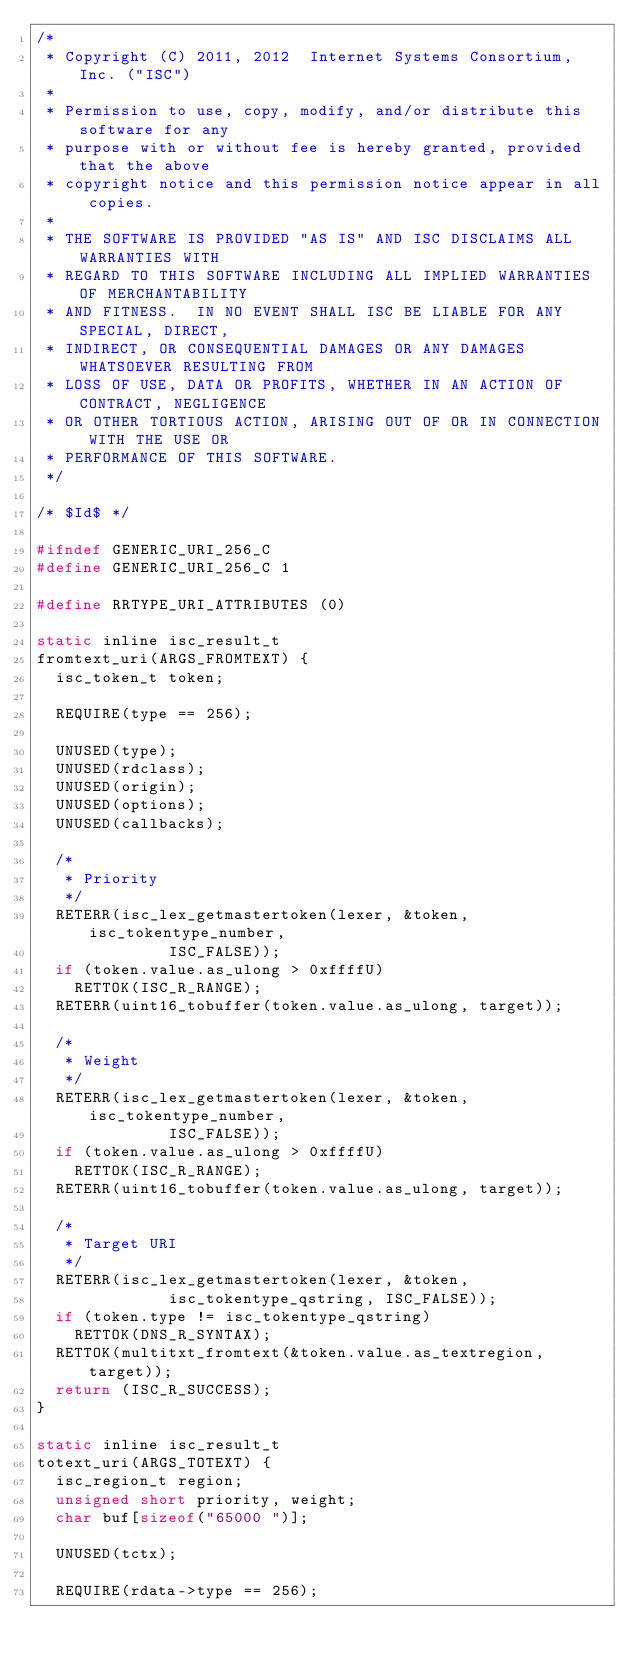Convert code to text. <code><loc_0><loc_0><loc_500><loc_500><_C_>/*
 * Copyright (C) 2011, 2012  Internet Systems Consortium, Inc. ("ISC")
 *
 * Permission to use, copy, modify, and/or distribute this software for any
 * purpose with or without fee is hereby granted, provided that the above
 * copyright notice and this permission notice appear in all copies.
 *
 * THE SOFTWARE IS PROVIDED "AS IS" AND ISC DISCLAIMS ALL WARRANTIES WITH
 * REGARD TO THIS SOFTWARE INCLUDING ALL IMPLIED WARRANTIES OF MERCHANTABILITY
 * AND FITNESS.  IN NO EVENT SHALL ISC BE LIABLE FOR ANY SPECIAL, DIRECT,
 * INDIRECT, OR CONSEQUENTIAL DAMAGES OR ANY DAMAGES WHATSOEVER RESULTING FROM
 * LOSS OF USE, DATA OR PROFITS, WHETHER IN AN ACTION OF CONTRACT, NEGLIGENCE
 * OR OTHER TORTIOUS ACTION, ARISING OUT OF OR IN CONNECTION WITH THE USE OR
 * PERFORMANCE OF THIS SOFTWARE.
 */

/* $Id$ */

#ifndef GENERIC_URI_256_C
#define GENERIC_URI_256_C 1

#define RRTYPE_URI_ATTRIBUTES (0)

static inline isc_result_t
fromtext_uri(ARGS_FROMTEXT) {
	isc_token_t token;

	REQUIRE(type == 256);

	UNUSED(type);
	UNUSED(rdclass);
	UNUSED(origin);
	UNUSED(options);
	UNUSED(callbacks);

	/*
	 * Priority
	 */
	RETERR(isc_lex_getmastertoken(lexer, &token, isc_tokentype_number,
				      ISC_FALSE));
	if (token.value.as_ulong > 0xffffU)
		RETTOK(ISC_R_RANGE);
	RETERR(uint16_tobuffer(token.value.as_ulong, target));

	/*
	 * Weight
	 */
	RETERR(isc_lex_getmastertoken(lexer, &token, isc_tokentype_number,
				      ISC_FALSE));
	if (token.value.as_ulong > 0xffffU)
		RETTOK(ISC_R_RANGE);
	RETERR(uint16_tobuffer(token.value.as_ulong, target));

	/*
	 * Target URI
	 */
	RETERR(isc_lex_getmastertoken(lexer, &token,
				      isc_tokentype_qstring, ISC_FALSE));
	if (token.type != isc_tokentype_qstring)
		RETTOK(DNS_R_SYNTAX);
	RETTOK(multitxt_fromtext(&token.value.as_textregion, target));
	return (ISC_R_SUCCESS);
}

static inline isc_result_t
totext_uri(ARGS_TOTEXT) {
	isc_region_t region;
	unsigned short priority, weight;
	char buf[sizeof("65000 ")];

	UNUSED(tctx);

	REQUIRE(rdata->type == 256);</code> 